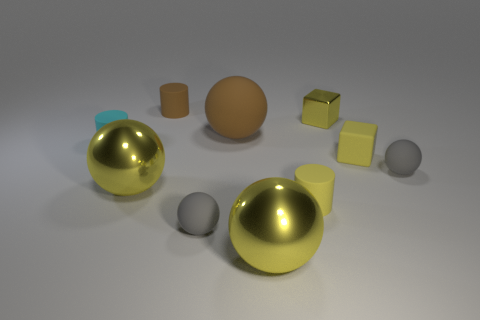Subtract 2 balls. How many balls are left? 3 Subtract all brown spheres. How many spheres are left? 4 Subtract all brown matte balls. How many balls are left? 4 Subtract all red balls. Subtract all red cubes. How many balls are left? 5 Subtract all cylinders. How many objects are left? 7 Subtract 1 brown balls. How many objects are left? 9 Subtract all yellow cylinders. Subtract all shiny cubes. How many objects are left? 8 Add 7 yellow rubber cubes. How many yellow rubber cubes are left? 8 Add 7 brown matte spheres. How many brown matte spheres exist? 8 